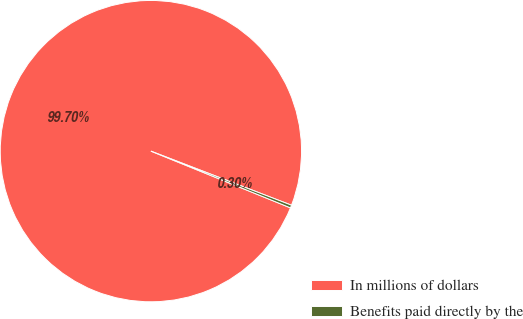Convert chart to OTSL. <chart><loc_0><loc_0><loc_500><loc_500><pie_chart><fcel>In millions of dollars<fcel>Benefits paid directly by the<nl><fcel>99.7%<fcel>0.3%<nl></chart> 